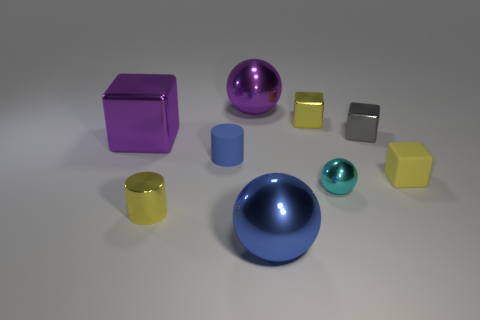What size is the rubber object that is the same color as the tiny metallic cylinder?
Give a very brief answer. Small. There is a matte cube; does it have the same color as the cylinder in front of the small blue cylinder?
Provide a succinct answer. Yes. What number of other objects are the same size as the yellow metallic cylinder?
Provide a succinct answer. 5. The rubber object to the right of the metallic sphere on the right side of the big thing that is in front of the yellow rubber object is what shape?
Provide a succinct answer. Cube. There is a yellow rubber object; does it have the same size as the blue object that is behind the small cyan metallic object?
Give a very brief answer. Yes. What is the color of the tiny thing that is to the left of the big blue shiny ball and right of the yellow metal cylinder?
Offer a terse response. Blue. What number of other things are there of the same shape as the blue metal thing?
Make the answer very short. 2. Does the metal cube that is on the left side of the small blue matte thing have the same color as the ball that is behind the small blue rubber cylinder?
Your response must be concise. Yes. Does the object in front of the yellow cylinder have the same size as the metallic sphere behind the purple metal cube?
Keep it short and to the point. Yes. What is the purple object behind the gray metallic cube that is behind the large metal object in front of the yellow rubber thing made of?
Provide a short and direct response. Metal. 